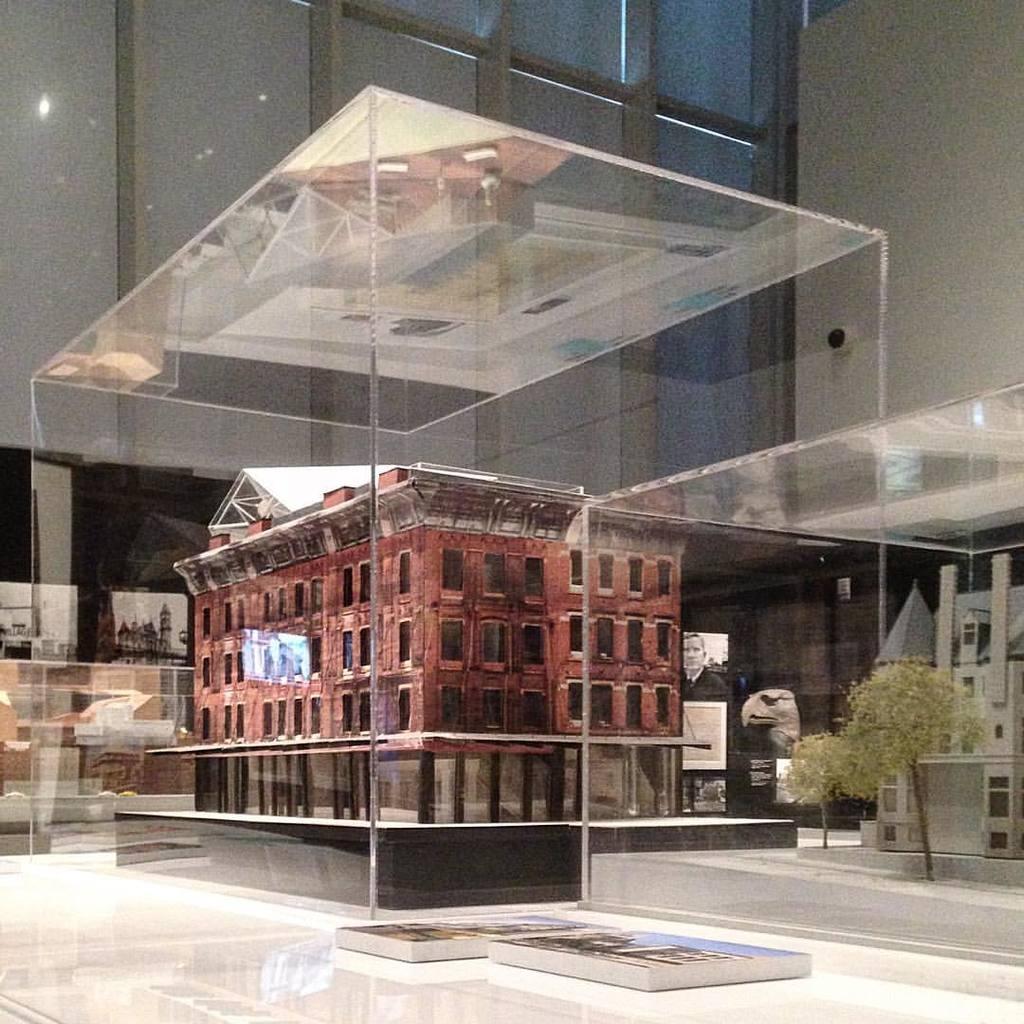Describe this image in one or two sentences. In this picture I can see a glass box in which we can see an architecture of the building. 